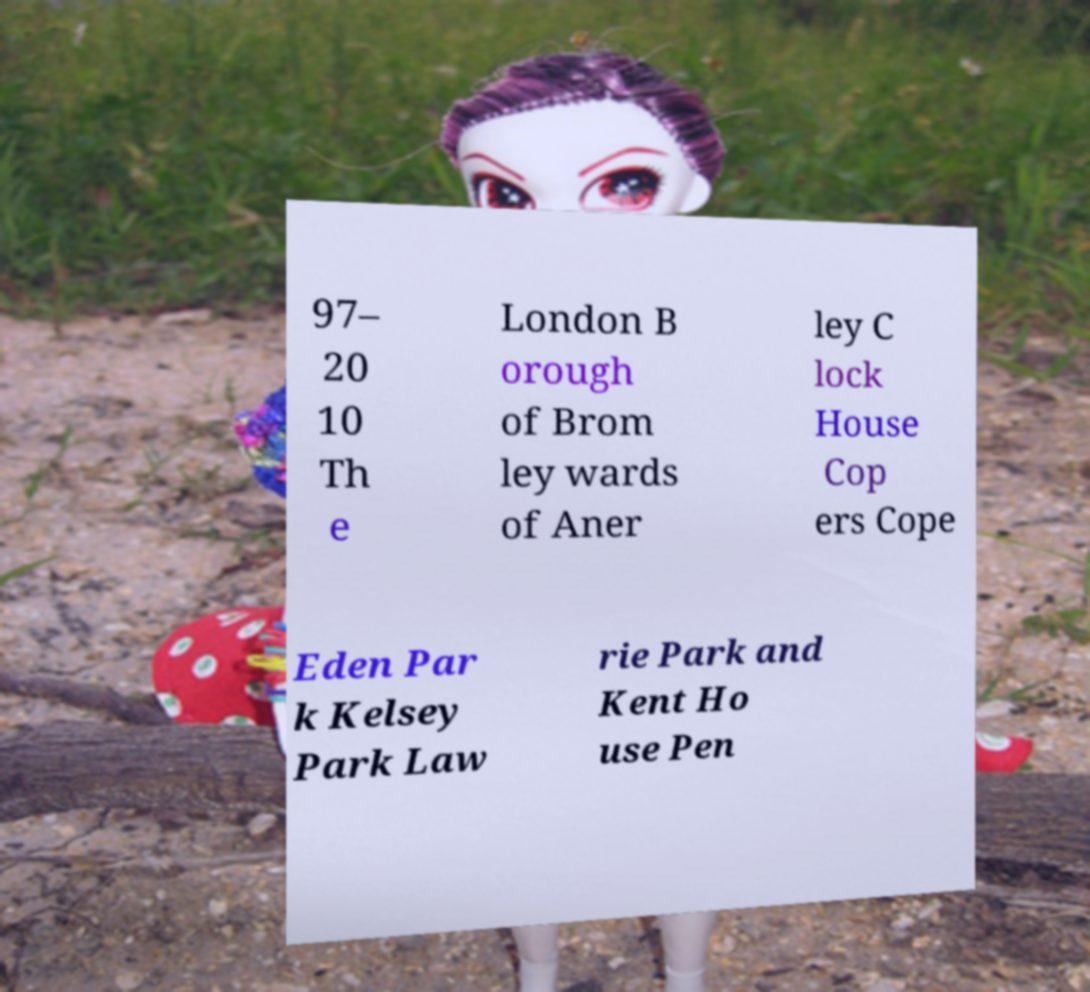Can you accurately transcribe the text from the provided image for me? 97– 20 10 Th e London B orough of Brom ley wards of Aner ley C lock House Cop ers Cope Eden Par k Kelsey Park Law rie Park and Kent Ho use Pen 